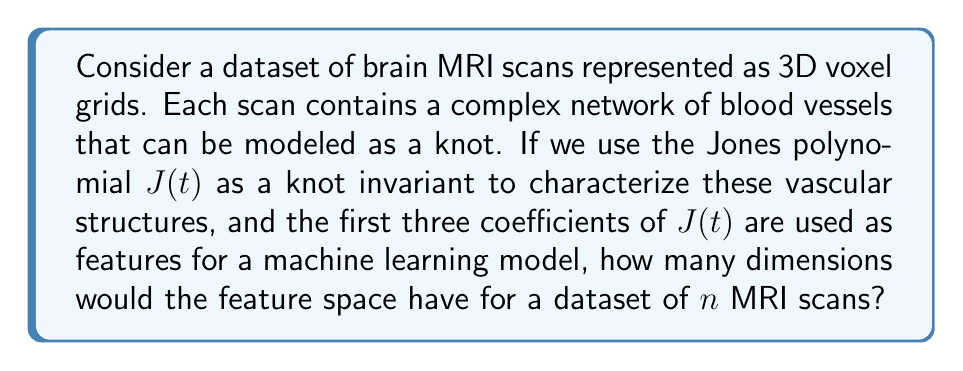Teach me how to tackle this problem. To solve this problem, let's break it down step-by-step:

1. The Jones polynomial $J(t)$ is a knot invariant that can be expressed as a Laurent polynomial:

   $J(t) = a_mt^m + a_{m+1}t^{m+1} + ... + a_0 + ... + a_{n-1}t^{n-1} + a_nt^n$

2. We are told that we're using the first three coefficients of $J(t)$ as features. These would typically be $a_0$, $a_1$, and $a_2$, regardless of the full range of the polynomial.

3. For each MRI scan, we extract these three coefficients, giving us three numerical features per scan.

4. In machine learning, each feature represents a dimension in the feature space.

5. Since we have three features per scan, each scan will be represented as a point in a 3-dimensional feature space.

6. The question asks about the dimensionality for a dataset of $n$ MRI scans. It's important to note that the number of samples (n) doesn't affect the dimensionality of the feature space.

7. Regardless of how many scans we have, we still only have three features (the three coefficients) per scan.

Therefore, the feature space will always have 3 dimensions, regardless of the number of scans in the dataset.
Answer: 3 